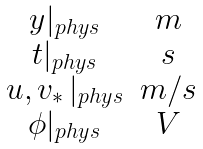<formula> <loc_0><loc_0><loc_500><loc_500>\begin{array} { c c } y | _ { p h y s } & m \\ t | _ { p h y s } & s \\ u , v _ { \ast } \, | _ { p h y s } & m / s \\ \phi | _ { p h y s } & V \end{array}</formula> 